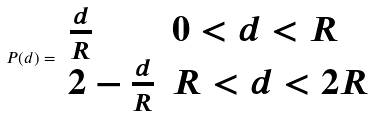<formula> <loc_0><loc_0><loc_500><loc_500>P ( d ) = \begin{array} { l l } \frac { d } { R } & 0 < d < R \\ 2 - \frac { d } { R } & R < d < 2 R \end{array}</formula> 